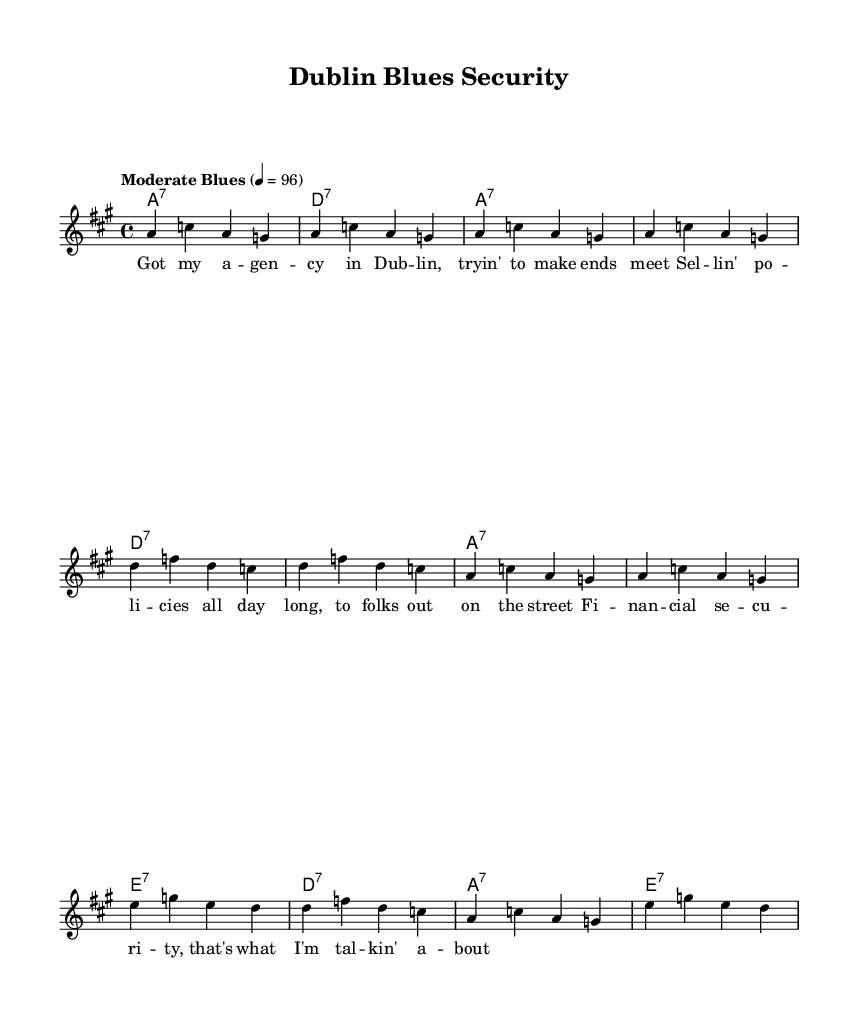What is the key signature of this music? The key signature is A major, which has three sharps (F#, C#, and G#). This can be identified by looking at the key signature indicated at the beginning of the staff.
Answer: A major What is the time signature of this music? The time signature is 4/4, meaning there are four beats in a measure and a quarter note receives one beat. This is indicated at the beginning of the sheet music.
Answer: 4/4 What is the tempo marking for this piece? The tempo marking is "Moderate Blues" at a quarter note = 96 beats per minute. This marking is shown above the staff and indicates how fast the music should be played.
Answer: Moderate Blues 4 = 96 How many measures are in the verse? There are twelve measures in the verse, as it is laid out sequentially through the entire melody section. Counting each line from the beginning to the end of the verse leads to this total.
Answer: 12 What chords are used in the first measure? The chord in the first measure is A7. This can be found in the chord names section where the specific chords are indicated above the respective measures.
Answer: A7 What is the theme of the lyrics? The theme is financial security, as the lyrics discuss the speaker's experience with selling policies and trying to make ends meet. This is evident in the content of the lyrics provided.
Answer: Financial security What is the structure of the music in terms of lyrical content? The structure consists of one verse that expresses a personal narrative related to the theme. This can be noted from the lack of repeated or additional verses.
Answer: One verse 